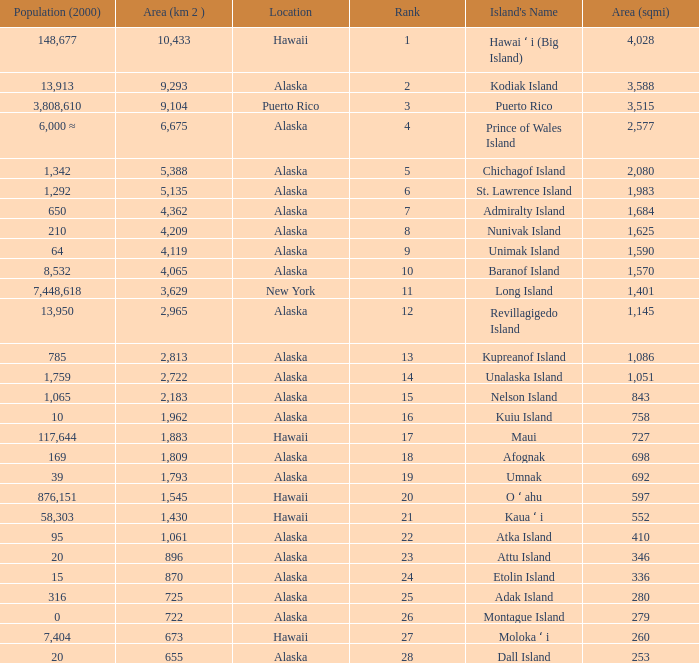What is the largest rank with 2,080 area? 5.0. 